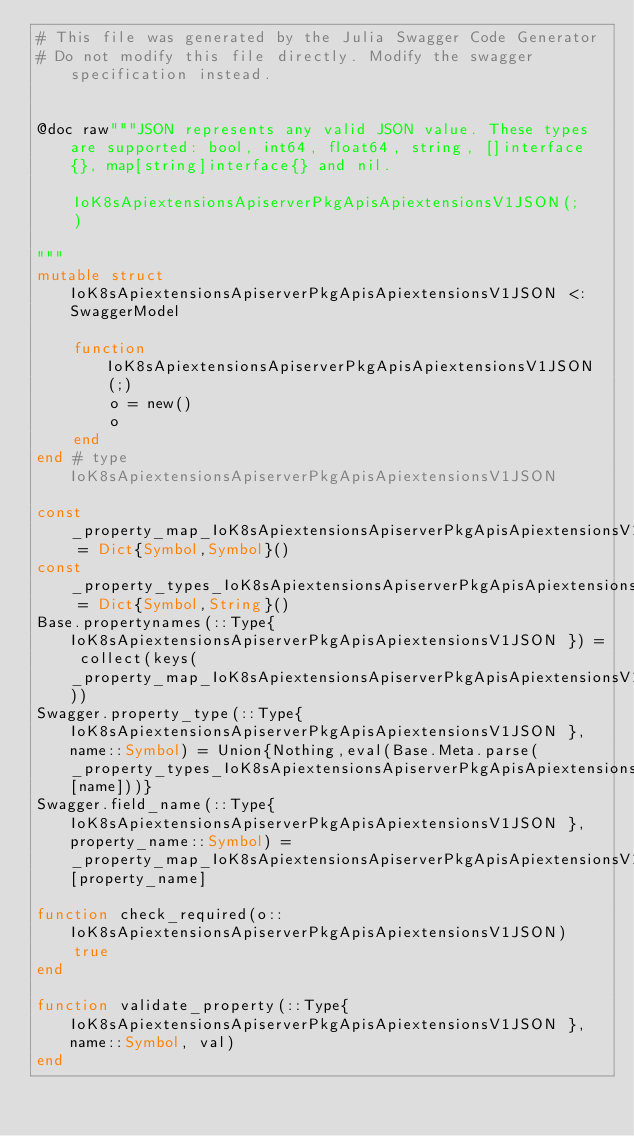<code> <loc_0><loc_0><loc_500><loc_500><_Julia_># This file was generated by the Julia Swagger Code Generator
# Do not modify this file directly. Modify the swagger specification instead.


@doc raw"""JSON represents any valid JSON value. These types are supported: bool, int64, float64, string, []interface{}, map[string]interface{} and nil.

    IoK8sApiextensionsApiserverPkgApisApiextensionsV1JSON(;
    )

"""
mutable struct IoK8sApiextensionsApiserverPkgApisApiextensionsV1JSON <: SwaggerModel

    function IoK8sApiextensionsApiserverPkgApisApiextensionsV1JSON(;)
        o = new()
        o
    end
end # type IoK8sApiextensionsApiserverPkgApisApiextensionsV1JSON

const _property_map_IoK8sApiextensionsApiserverPkgApisApiextensionsV1JSON = Dict{Symbol,Symbol}()
const _property_types_IoK8sApiextensionsApiserverPkgApisApiextensionsV1JSON = Dict{Symbol,String}()
Base.propertynames(::Type{ IoK8sApiextensionsApiserverPkgApisApiextensionsV1JSON }) = collect(keys(_property_map_IoK8sApiextensionsApiserverPkgApisApiextensionsV1JSON))
Swagger.property_type(::Type{ IoK8sApiextensionsApiserverPkgApisApiextensionsV1JSON }, name::Symbol) = Union{Nothing,eval(Base.Meta.parse(_property_types_IoK8sApiextensionsApiserverPkgApisApiextensionsV1JSON[name]))}
Swagger.field_name(::Type{ IoK8sApiextensionsApiserverPkgApisApiextensionsV1JSON }, property_name::Symbol) =  _property_map_IoK8sApiextensionsApiserverPkgApisApiextensionsV1JSON[property_name]

function check_required(o::IoK8sApiextensionsApiserverPkgApisApiextensionsV1JSON)
    true
end

function validate_property(::Type{ IoK8sApiextensionsApiserverPkgApisApiextensionsV1JSON }, name::Symbol, val)
end
</code> 